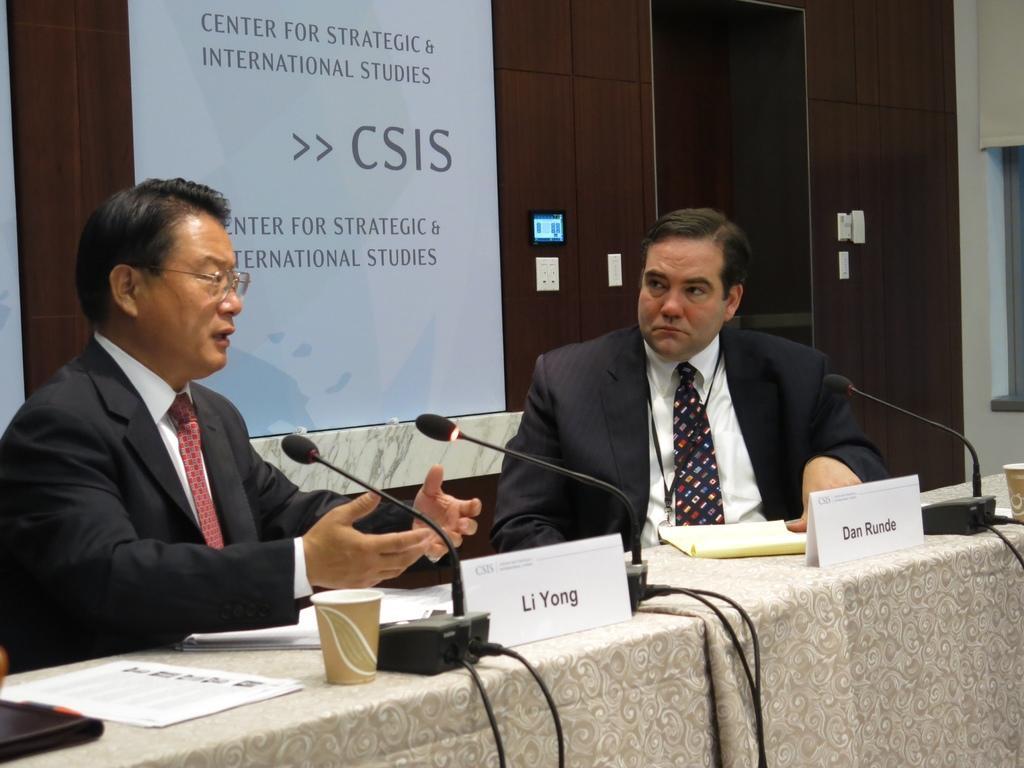Can you describe this image briefly? In this image we can see there are two persons sitting in front of the table. We can see there are microphones, cups, boards with text and a few objects. In the background, we can see the screen with text and wood wall with sockets. 